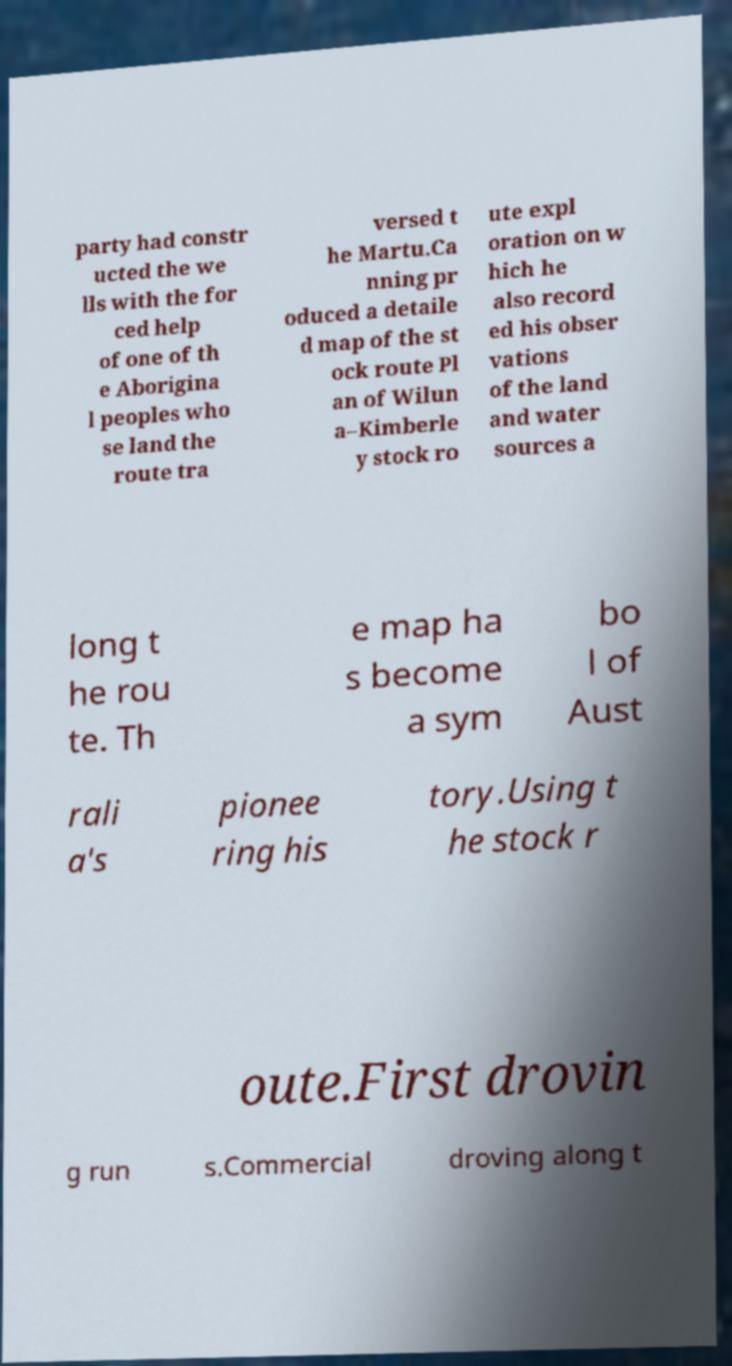For documentation purposes, I need the text within this image transcribed. Could you provide that? party had constr ucted the we lls with the for ced help of one of th e Aborigina l peoples who se land the route tra versed t he Martu.Ca nning pr oduced a detaile d map of the st ock route Pl an of Wilun a–Kimberle y stock ro ute expl oration on w hich he also record ed his obser vations of the land and water sources a long t he rou te. Th e map ha s become a sym bo l of Aust rali a's pionee ring his tory.Using t he stock r oute.First drovin g run s.Commercial droving along t 